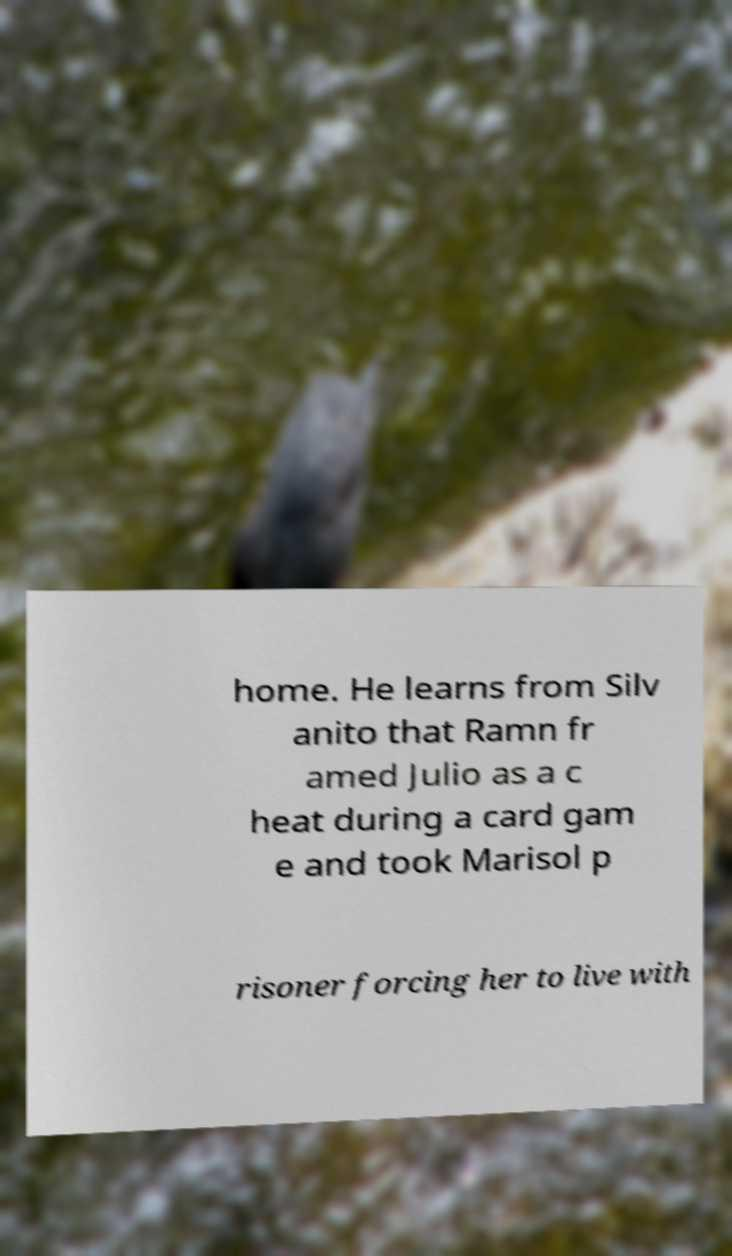What messages or text are displayed in this image? I need them in a readable, typed format. home. He learns from Silv anito that Ramn fr amed Julio as a c heat during a card gam e and took Marisol p risoner forcing her to live with 